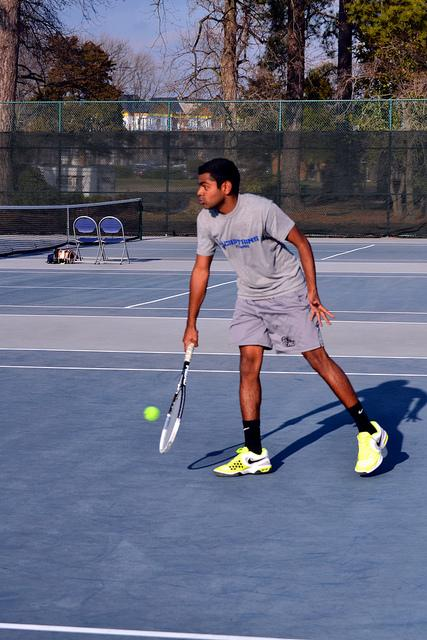Which object is in motion? Please explain your reasoning. ball. It is in midair 